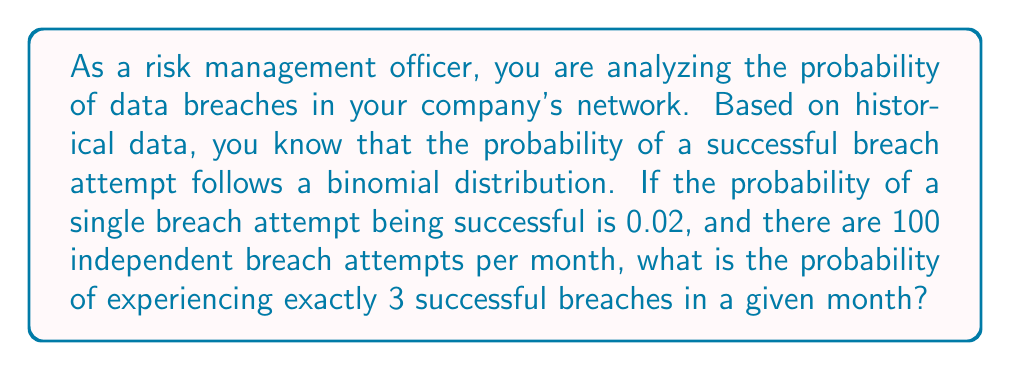Could you help me with this problem? To solve this problem, we'll use the binomial probability formula:

$$ P(X = k) = \binom{n}{k} p^k (1-p)^{n-k} $$

Where:
$n$ = number of trials (breach attempts)
$k$ = number of successes (successful breaches)
$p$ = probability of success on a single trial

Given:
$n = 100$
$k = 3$
$p = 0.02$

Step 1: Calculate the binomial coefficient
$$ \binom{n}{k} = \binom{100}{3} = \frac{100!}{3!(100-3)!} = \frac{100!}{3!97!} = 161,700 $$

Step 2: Calculate $p^k$
$$ p^k = 0.02^3 = 0.000008 $$

Step 3: Calculate $(1-p)^{n-k}$
$$ (1-p)^{n-k} = 0.98^{97} \approx 0.1353 $$

Step 4: Multiply all components
$$ P(X = 3) = 161,700 \times 0.000008 \times 0.1353 \approx 0.1749 $$

Therefore, the probability of experiencing exactly 3 successful breaches in a given month is approximately 0.1749 or 17.49%.
Answer: 0.1749 or 17.49% 